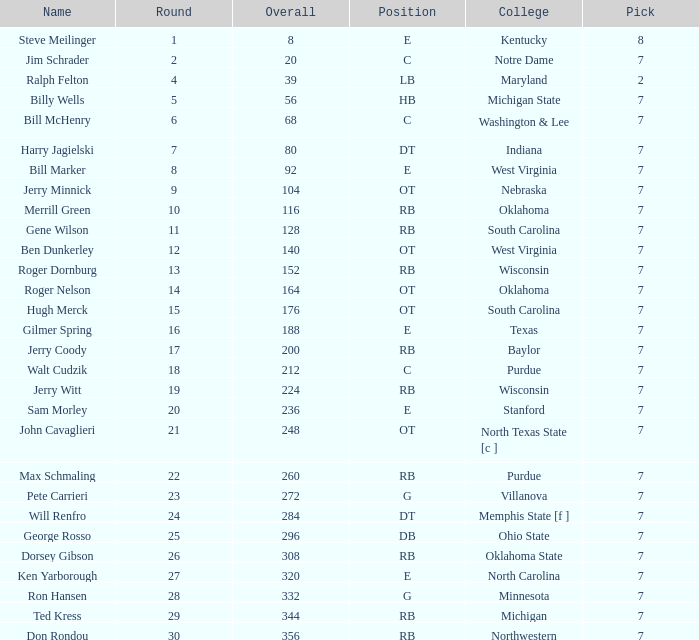What pick did George Rosso get drafted when the overall was less than 296? 0.0. 